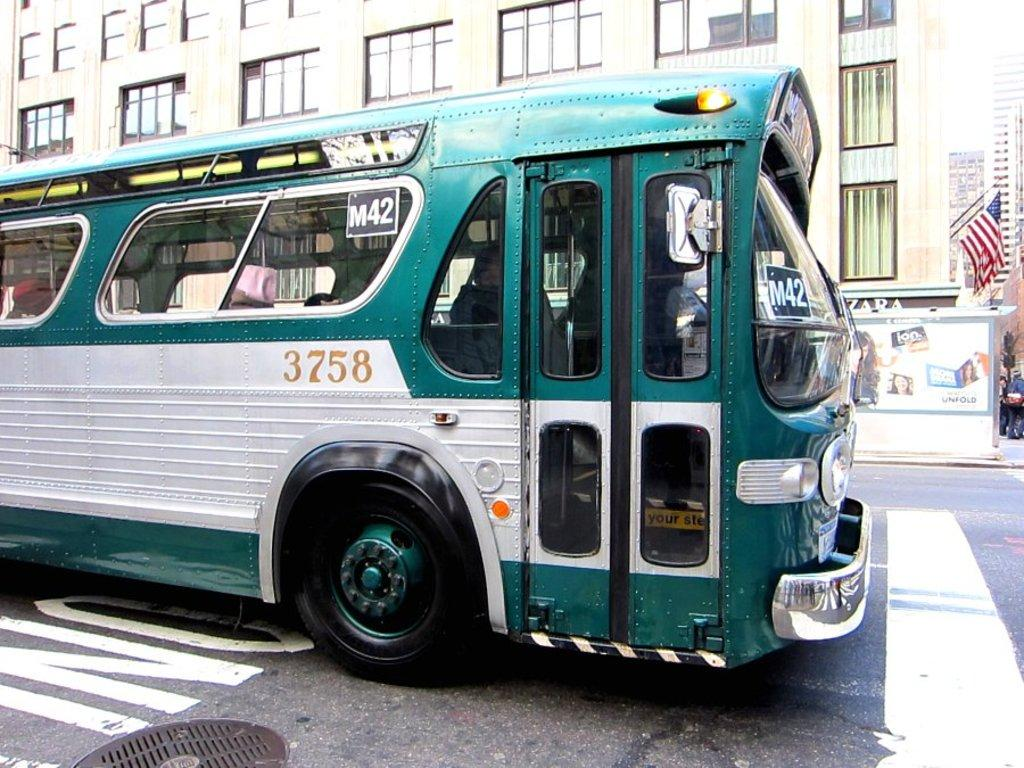What is the main subject of the image? There is a bus in the image. Where is the bus located in relation to other objects? The bus is in front of a building. What can be seen on the right side of the image? There is a flag on the right side of the image. What is located in the bottom left of the image? There is a manhole in the bottom left of the image. What type of pest can be seen crawling on the bus in the image? There are no pests visible on the bus in the image. What type of can is present on the bus in the image? There is no can present on the bus in the image. 